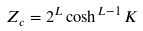Convert formula to latex. <formula><loc_0><loc_0><loc_500><loc_500>Z _ { c } = 2 ^ { L } \cosh ^ { L - 1 } K</formula> 